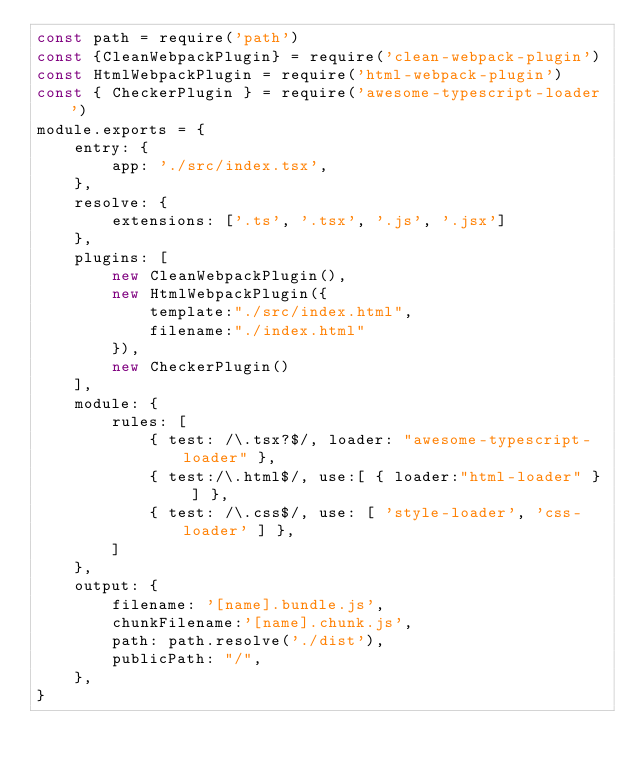Convert code to text. <code><loc_0><loc_0><loc_500><loc_500><_JavaScript_>const path = require('path')
const {CleanWebpackPlugin} = require('clean-webpack-plugin')
const HtmlWebpackPlugin = require('html-webpack-plugin')
const { CheckerPlugin } = require('awesome-typescript-loader')
module.exports = {
    entry: {
        app: './src/index.tsx',
    },
    resolve: {
        extensions: ['.ts', '.tsx', '.js', '.jsx']
    },
    plugins: [
        new CleanWebpackPlugin(),
        new HtmlWebpackPlugin({
            template:"./src/index.html",
            filename:"./index.html"
        }),
        new CheckerPlugin()
    ],
    module: {
        rules: [
            { test: /\.tsx?$/, loader: "awesome-typescript-loader" },
            { test:/\.html$/, use:[ { loader:"html-loader" } ] },
            { test: /\.css$/, use: [ 'style-loader', 'css-loader' ] },
        ]
    },
    output: {
        filename: '[name].bundle.js',
        chunkFilename:'[name].chunk.js',
        path: path.resolve('./dist'),
        publicPath: "/",
    },
}
</code> 